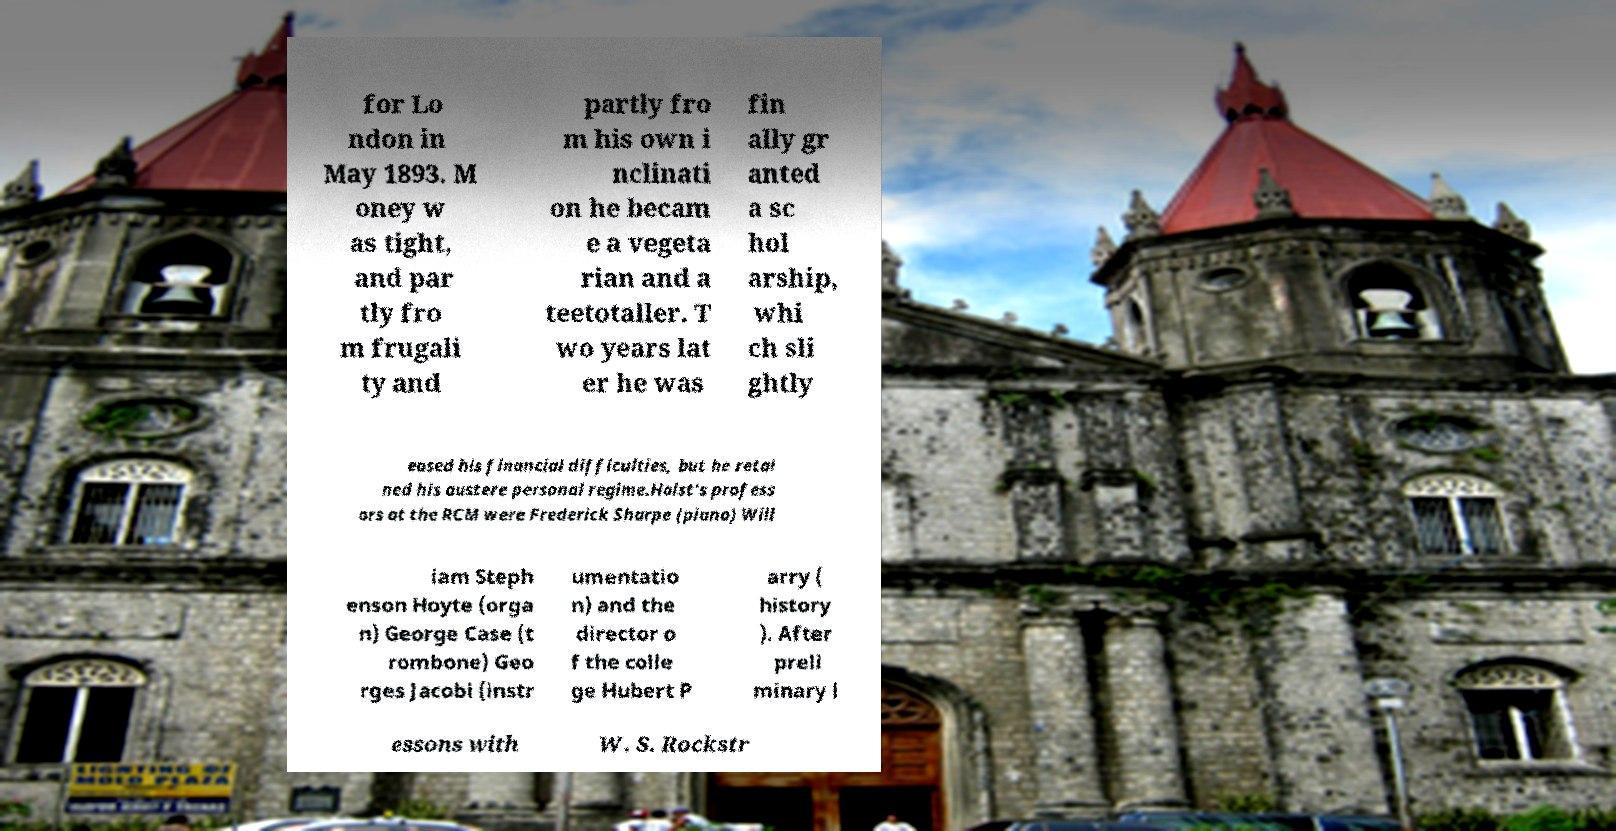Can you accurately transcribe the text from the provided image for me? for Lo ndon in May 1893. M oney w as tight, and par tly fro m frugali ty and partly fro m his own i nclinati on he becam e a vegeta rian and a teetotaller. T wo years lat er he was fin ally gr anted a sc hol arship, whi ch sli ghtly eased his financial difficulties, but he retai ned his austere personal regime.Holst's profess ors at the RCM were Frederick Sharpe (piano) Will iam Steph enson Hoyte (orga n) George Case (t rombone) Geo rges Jacobi (instr umentatio n) and the director o f the colle ge Hubert P arry ( history ). After preli minary l essons with W. S. Rockstr 